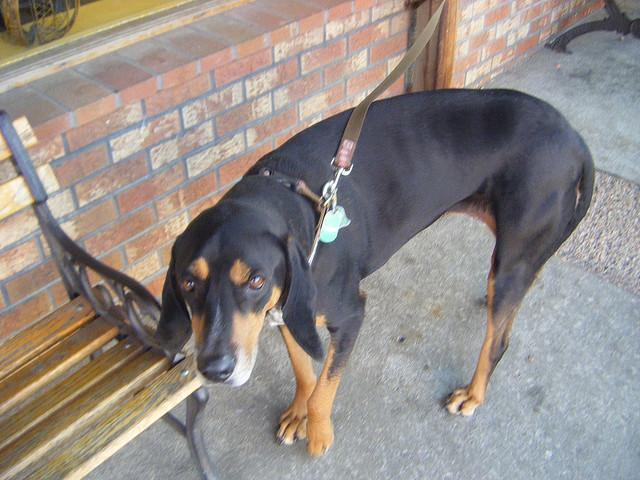Is the dog jumping?
Keep it brief. No. Is the dog tied to something?
Short answer required. Yes. What type of dog is this?
Write a very short answer. Doberman. 